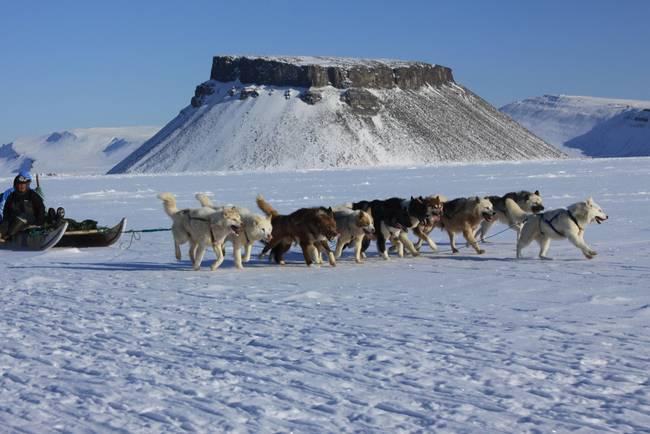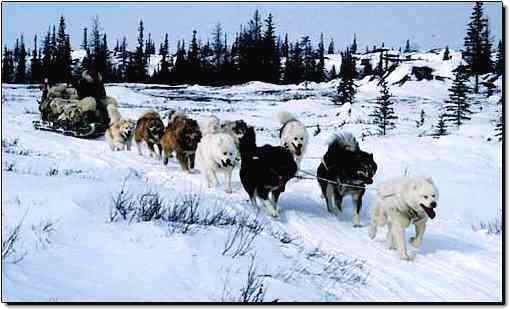The first image is the image on the left, the second image is the image on the right. For the images shown, is this caption "Some of the dogs are sitting." true? Answer yes or no. No. The first image is the image on the left, the second image is the image on the right. Examine the images to the left and right. Is the description "There are dogs resting." accurate? Answer yes or no. No. 